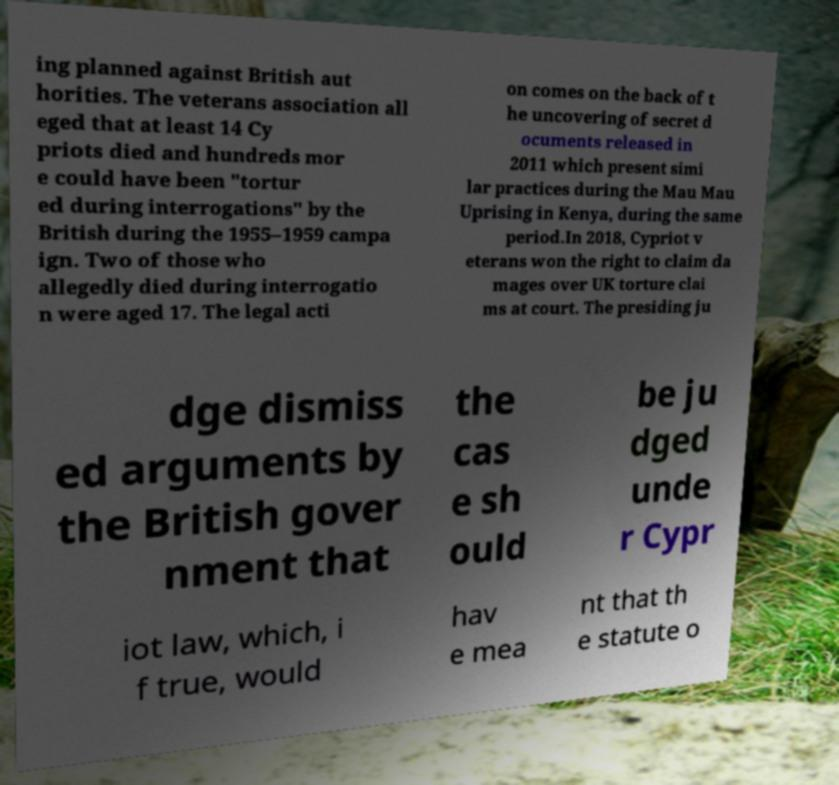Could you extract and type out the text from this image? ing planned against British aut horities. The veterans association all eged that at least 14 Cy priots died and hundreds mor e could have been "tortur ed during interrogations" by the British during the 1955–1959 campa ign. Two of those who allegedly died during interrogatio n were aged 17. The legal acti on comes on the back of t he uncovering of secret d ocuments released in 2011 which present simi lar practices during the Mau Mau Uprising in Kenya, during the same period.In 2018, Cypriot v eterans won the right to claim da mages over UK torture clai ms at court. The presiding ju dge dismiss ed arguments by the British gover nment that the cas e sh ould be ju dged unde r Cypr iot law, which, i f true, would hav e mea nt that th e statute o 